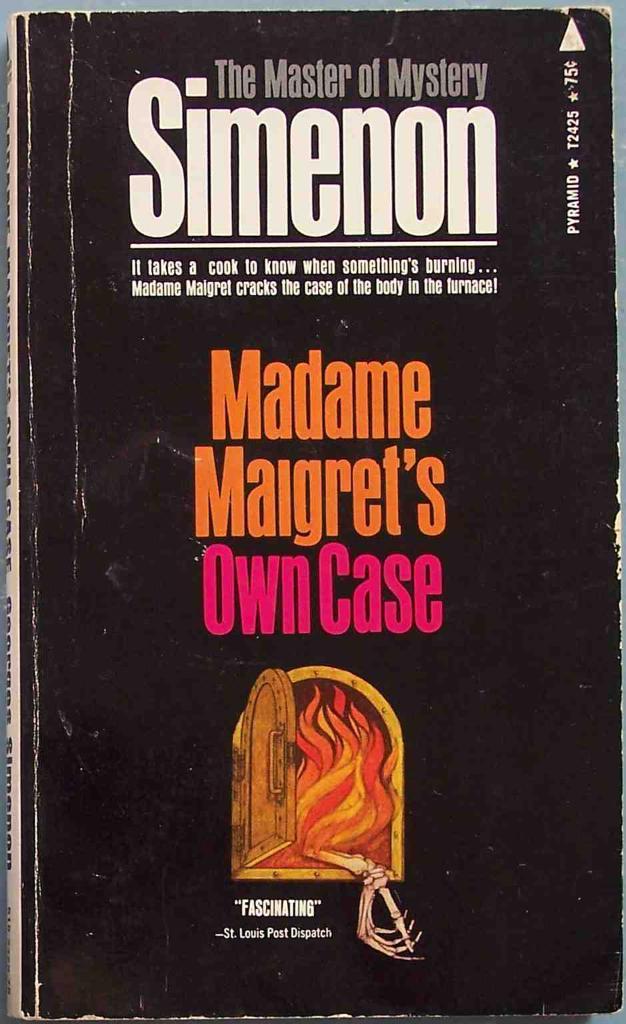Please provide a concise description of this image. This is a zoomed in picture. In the center there is a black color book and we can see the text is printed on the book and we can see a picture of a fire and a window on the cover of a book. 